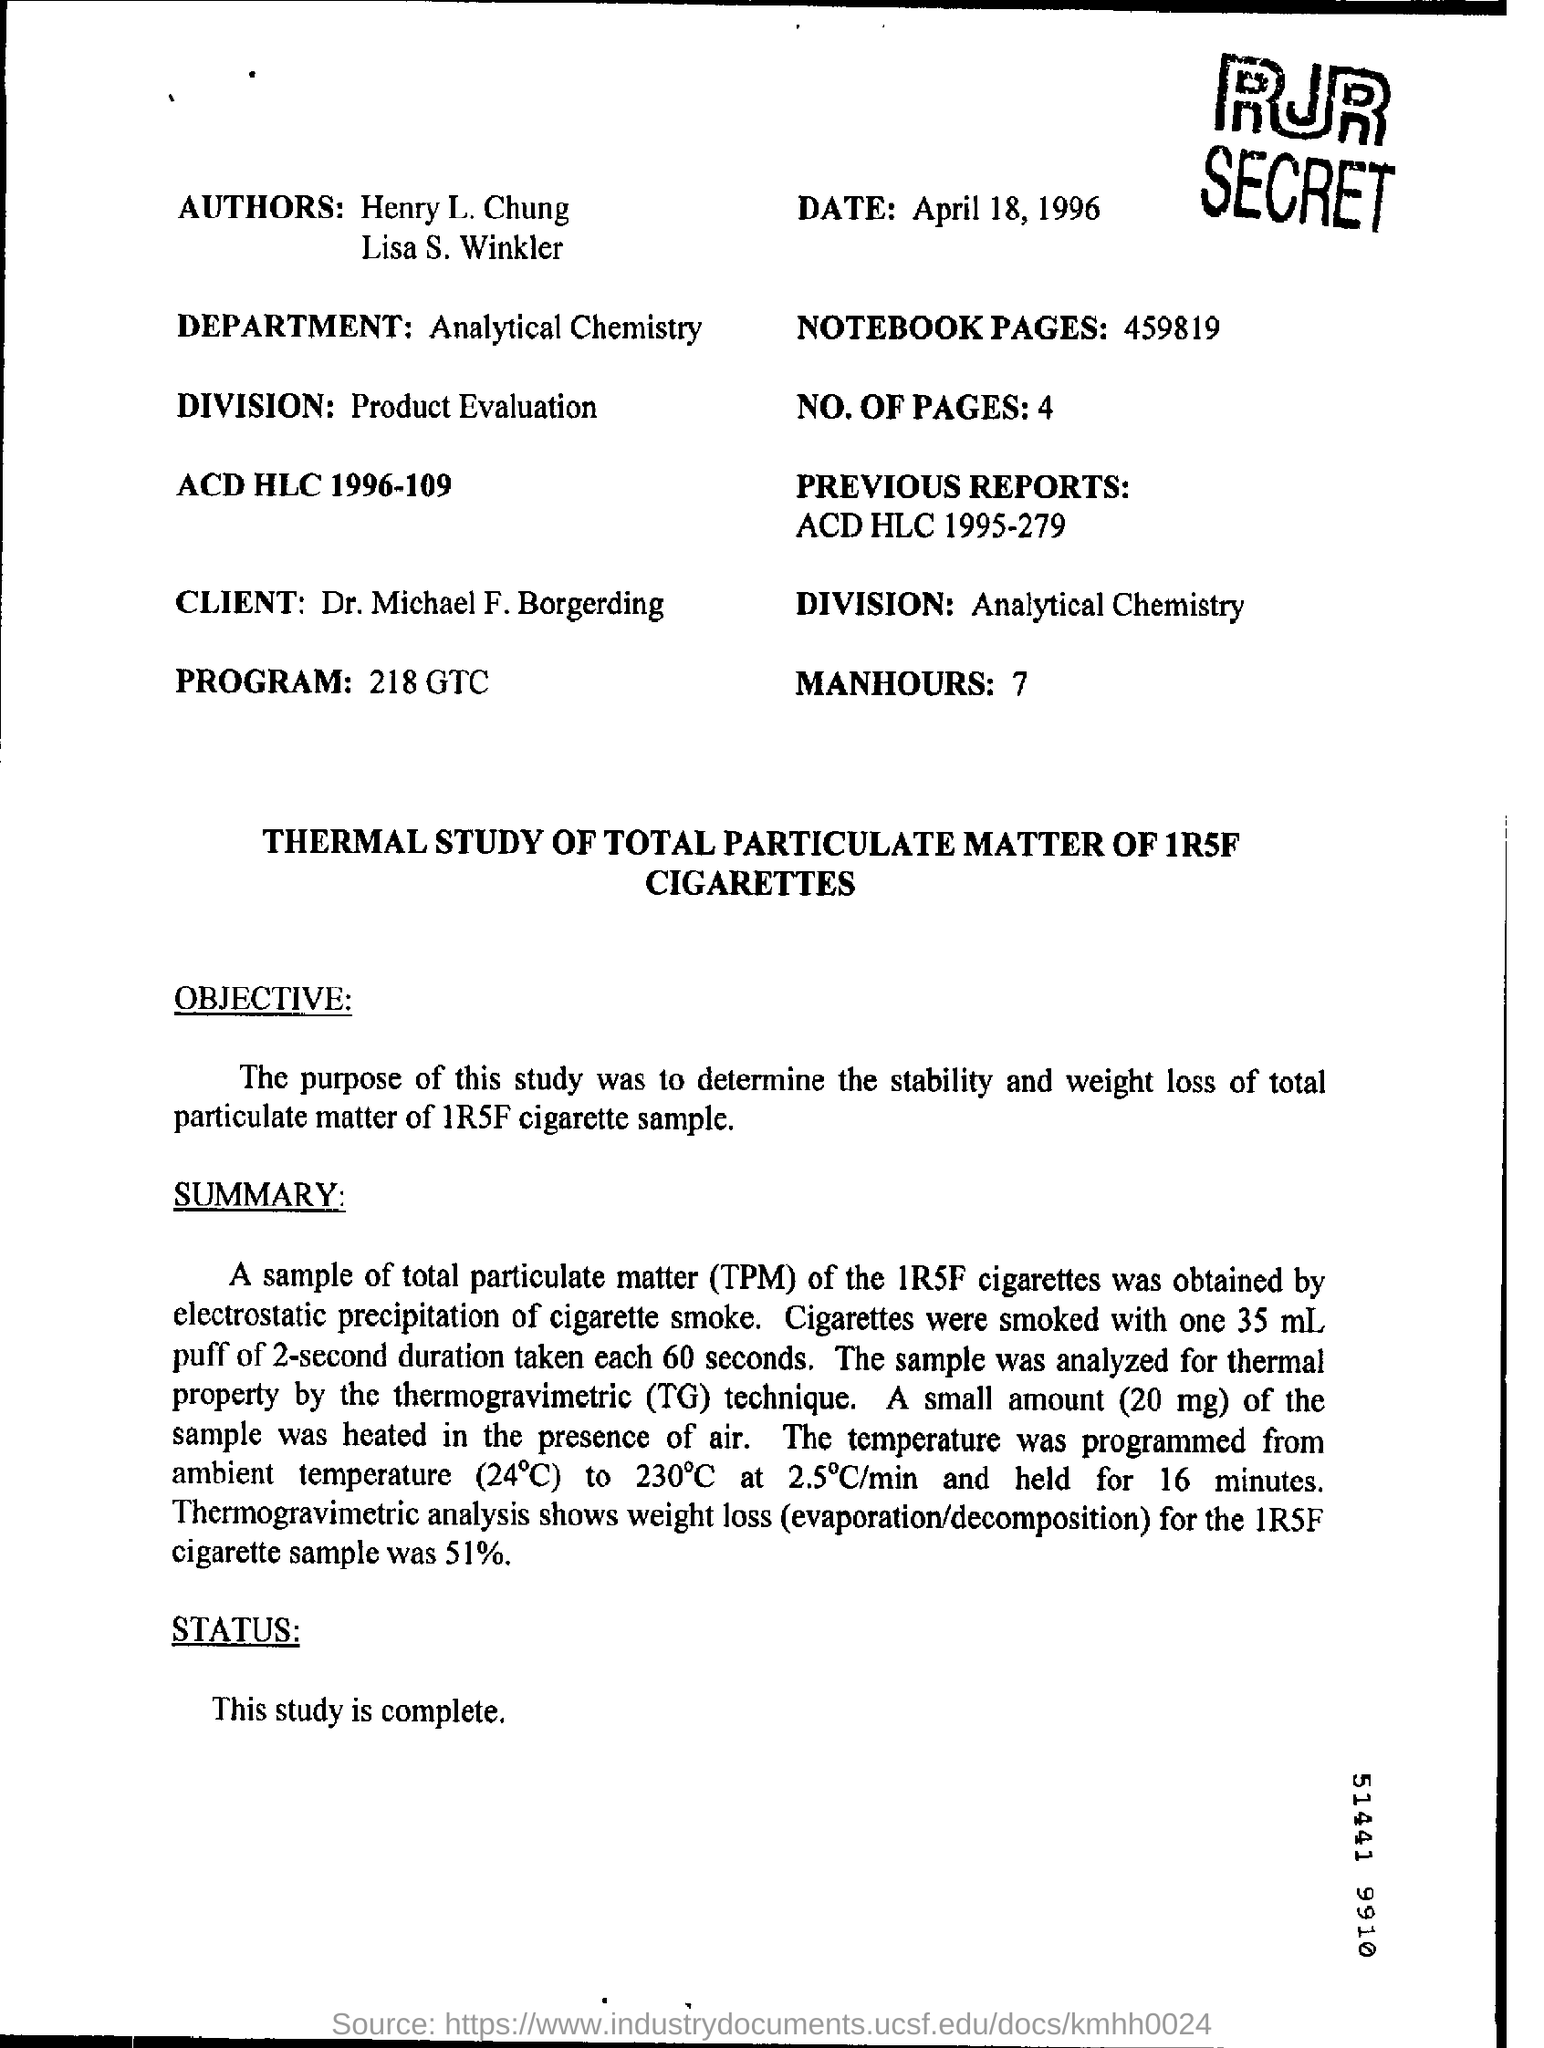Identify some key points in this picture. The client's primary area of focus is analytical chemistry, and it is commonly referred to as division. The first person among the "authors" is named Henry L. Chung. The department is Analytical Chemistry. The client is Dr. Michael F. Borgerding. The study is now complete. 